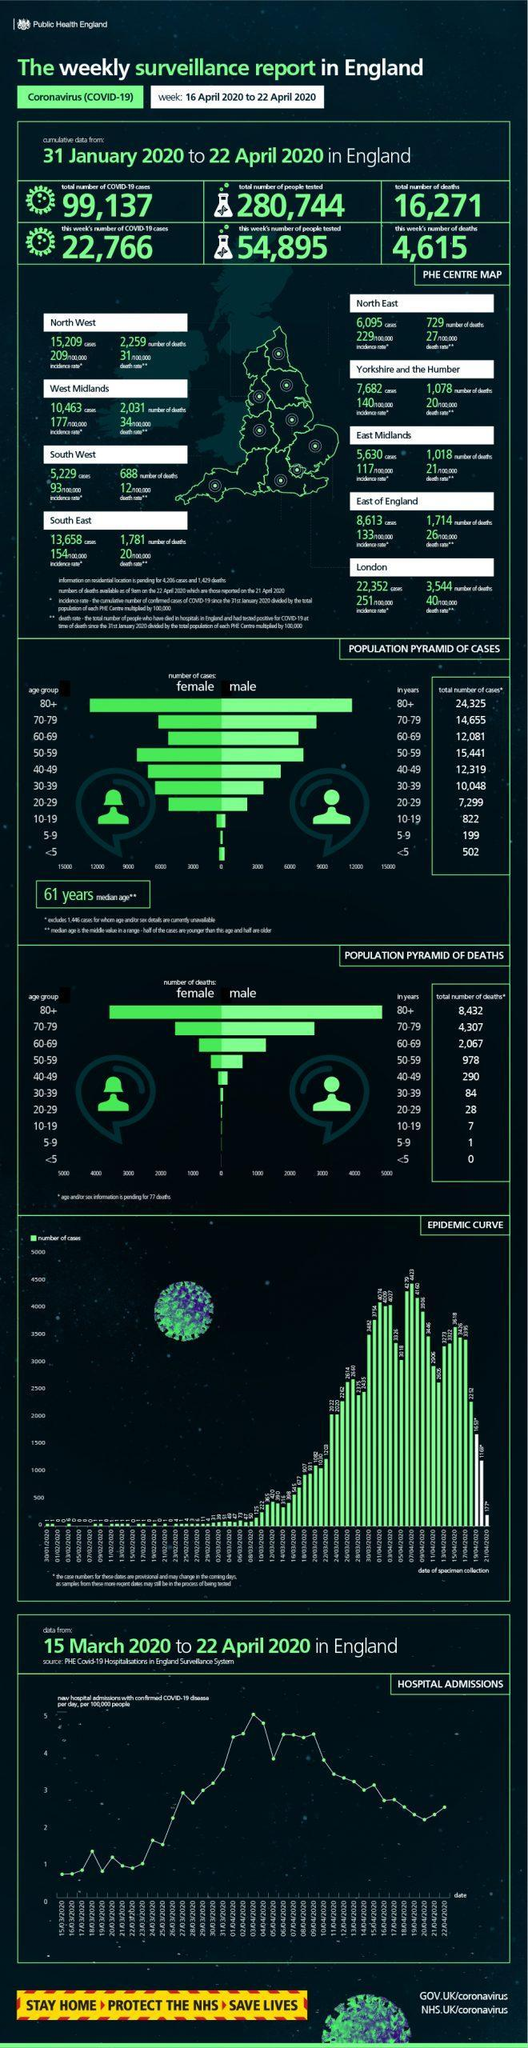How many people were tested for COVID-19 during 16 April 2020 - 22 April 2020 in England?
Answer the question with a short phrase. 54,895 What is the total number of people tested for COVID-19 during 31 January 2020 - 22 April 2020 in England? 280,744 What is the number of COVID-19 deaths reported during 16 April 2020 - 22 April 2020 in England? 4,615 What is the total number of deaths reported in children aged between 10-19 years during 31 January 2020 - 22 April 2020 in England? 7 How many COVID-19 deaths were reported in London during 31 January 2020 - 22 April 2020? 3,544 In which age group, the highest number of  COVID-19 cases were reported during 31 January 2020 - 22 April 2020 in England? 80+ In which age group, least number of COVID-19 cases were reported during 31 January 2020 - 22 April 2020 in England? 5-9 What is the number of COVID-19 cases reported during 16 April 2020 - 22 April 2020 in England? 22,766 How many COVID-19 deaths were reported in people aged between 70-79 years during  31 January 2020 - 22 April 2020 in England? 4,307 How many COVID-19 cases were reported in the East of England during 31 January 2020 - 22 April 2020? 8,613 